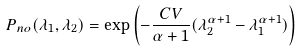Convert formula to latex. <formula><loc_0><loc_0><loc_500><loc_500>P _ { n o } ( \lambda _ { 1 } , \lambda _ { 2 } ) = \exp \left ( - \frac { C V } { \alpha + 1 } ( \lambda _ { 2 } ^ { \alpha + 1 } - \lambda _ { 1 } ^ { \alpha + 1 } ) \right )</formula> 